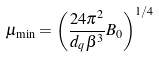Convert formula to latex. <formula><loc_0><loc_0><loc_500><loc_500>\mu _ { \min } = \left ( \frac { 2 4 \pi ^ { 2 } } { d _ { q } \beta ^ { 3 } } B _ { 0 } \right ) ^ { 1 / 4 }</formula> 